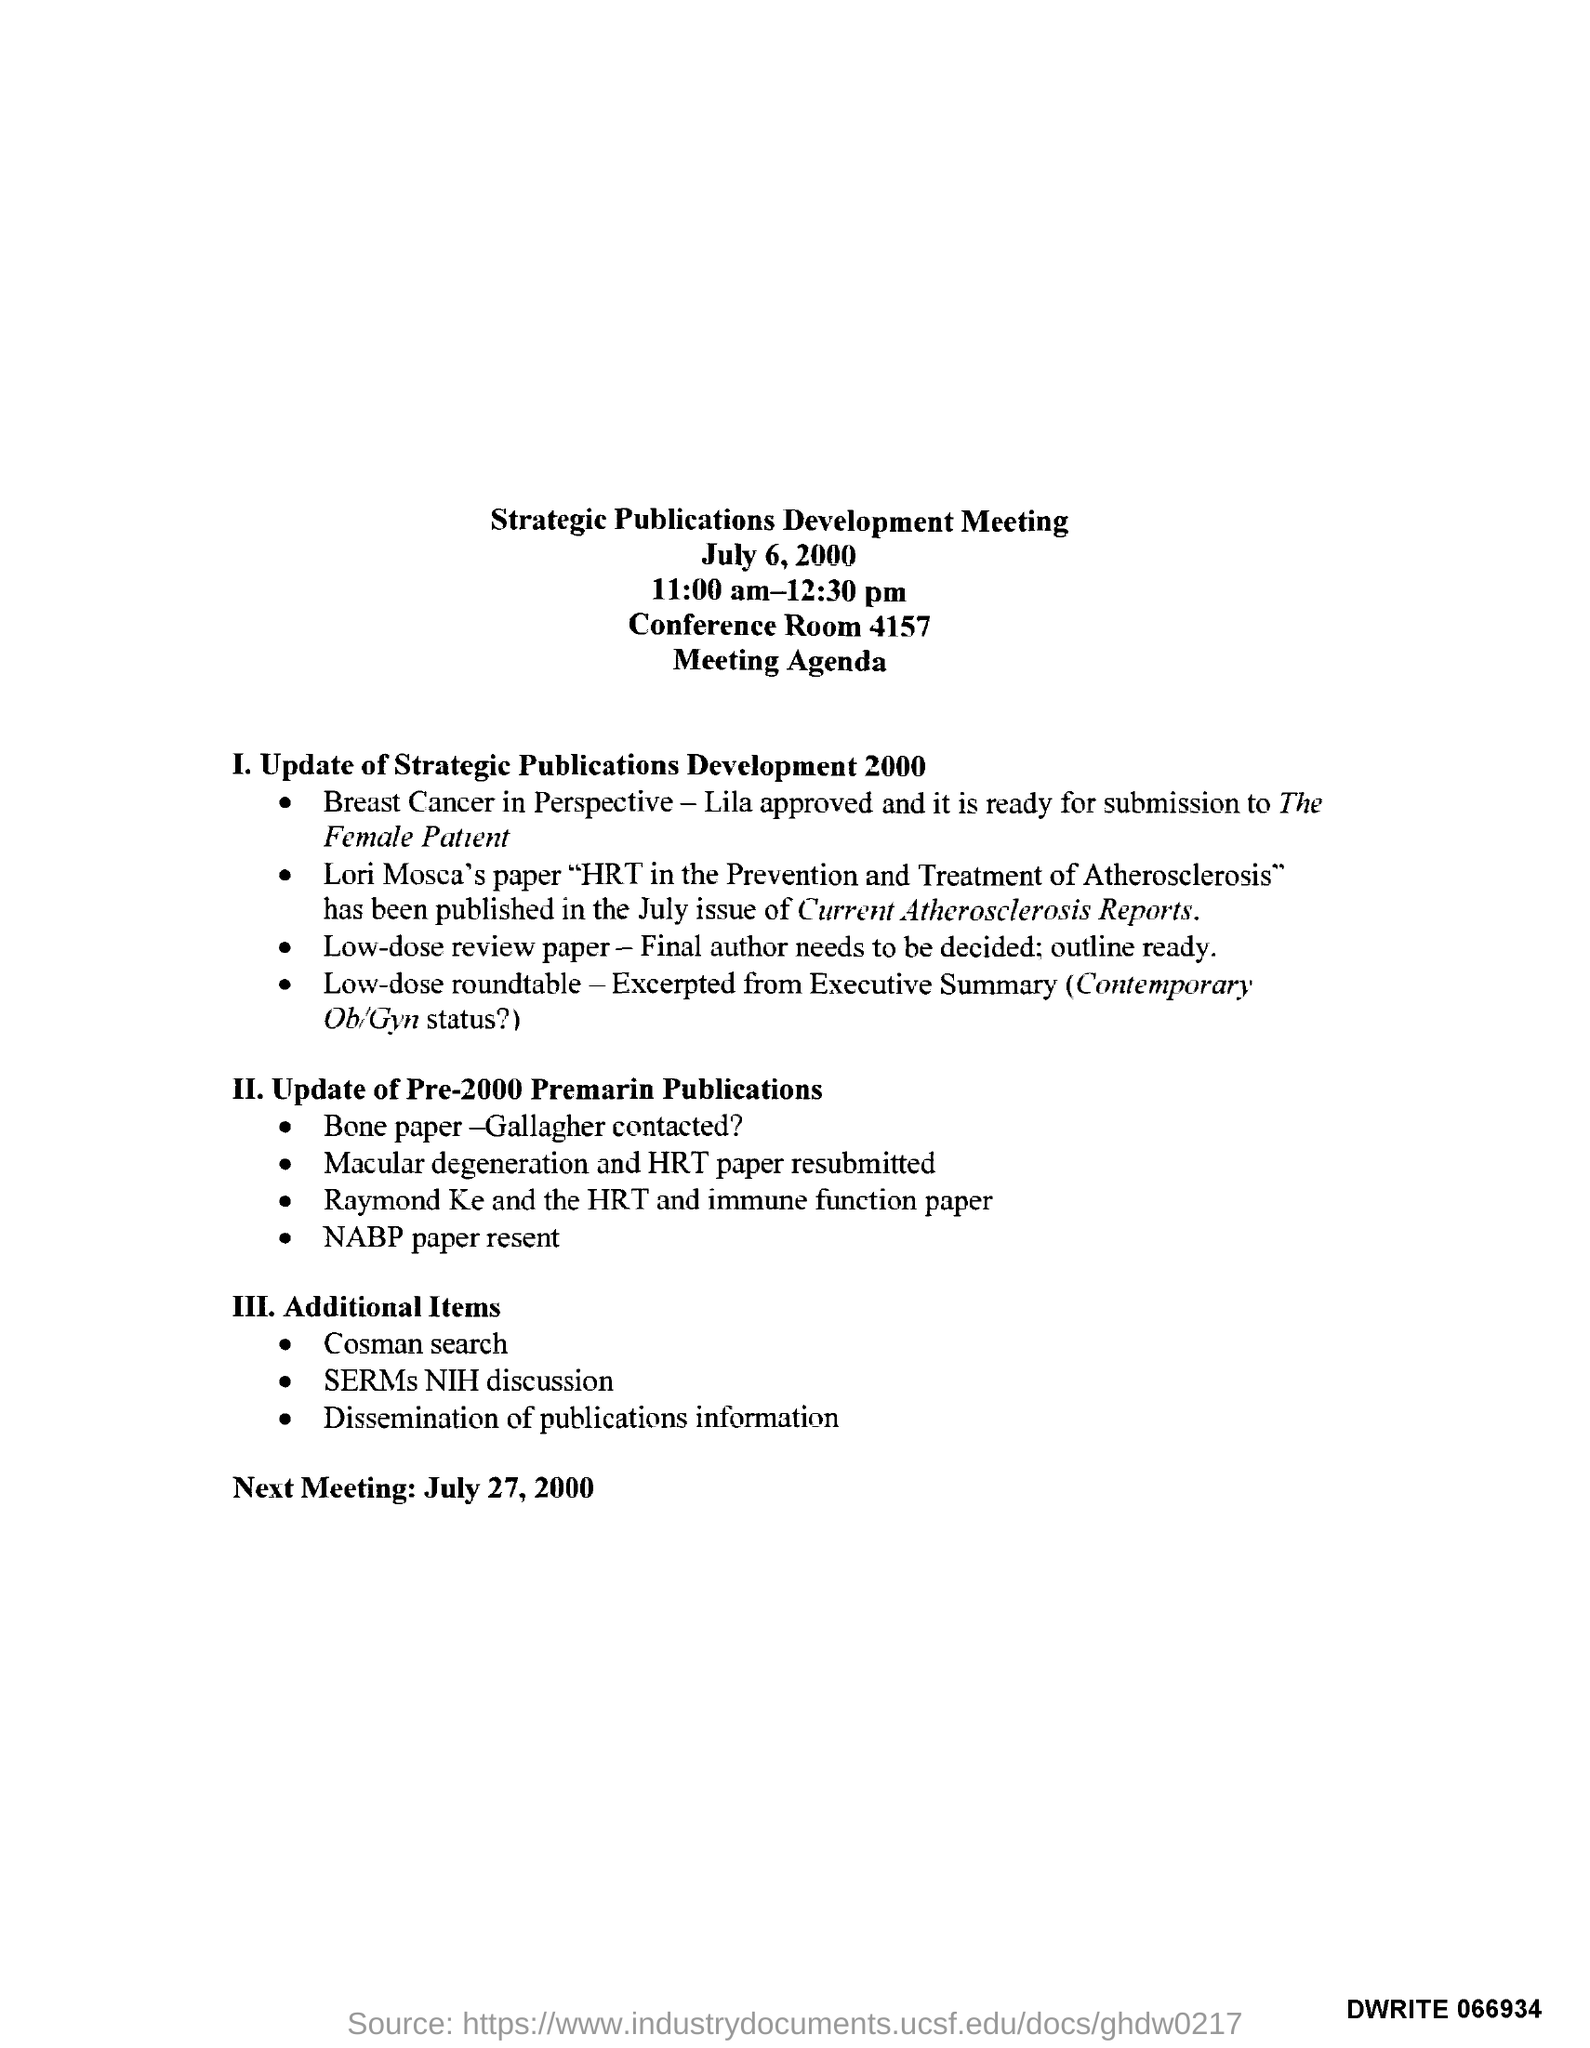What is the date mentioned in the top of the document ?
Your answer should be very brief. July 6, 2000. What is the Conference Room Number ?
Give a very brief answer. 4157. What is the Next meeting Date?
Keep it short and to the point. July 27, 2000. What is the Timing of Meeting ?
Keep it short and to the point. 11:00 am-12:30 pm. 